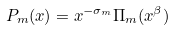<formula> <loc_0><loc_0><loc_500><loc_500>P _ { m } ( x ) = x ^ { - \sigma _ { m } } \Pi _ { m } ( x ^ { \beta } )</formula> 